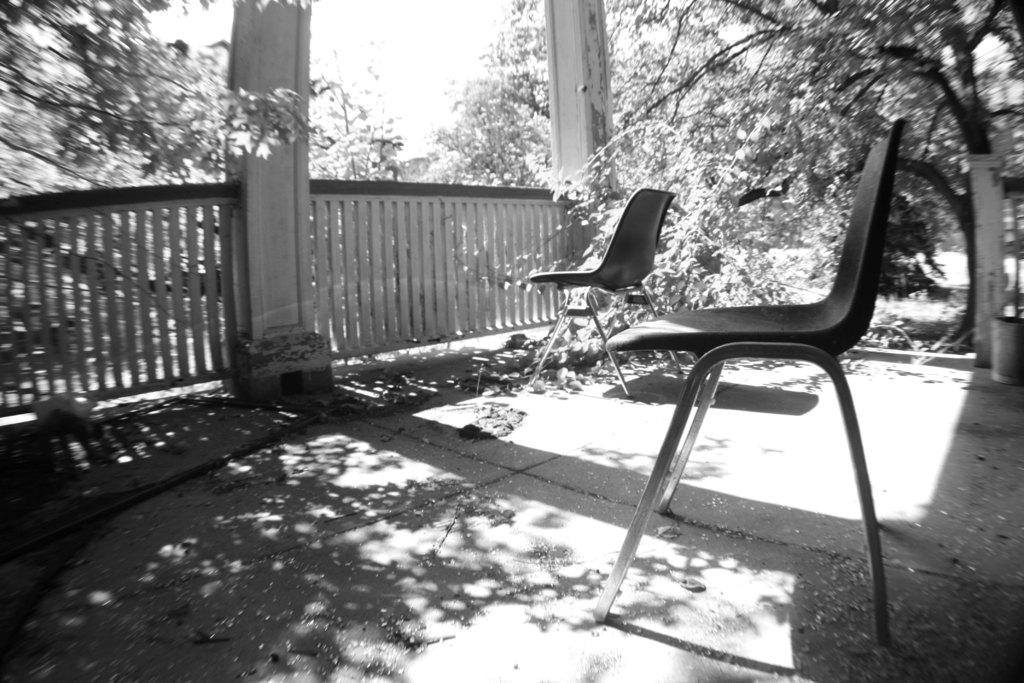What is the color scheme of the image? The image is black and white. What type of furniture can be seen on the floor in the image? There are chairs on the floor in the image. What architectural features are visible in the background of the image? There is a railing and pillars in the background of the image. What type of natural elements can be seen in the background of the image? There are trees in the background of the image. What type of trains are passing by in the image? There are no trains present in the image; it is a black and white image with chairs, a railing, pillars, and trees in the background. What nation is being celebrated in the image? There is no indication of a nation being celebrated in the image; it is a simple scene with chairs, a railing, pillars, and trees in the background. 